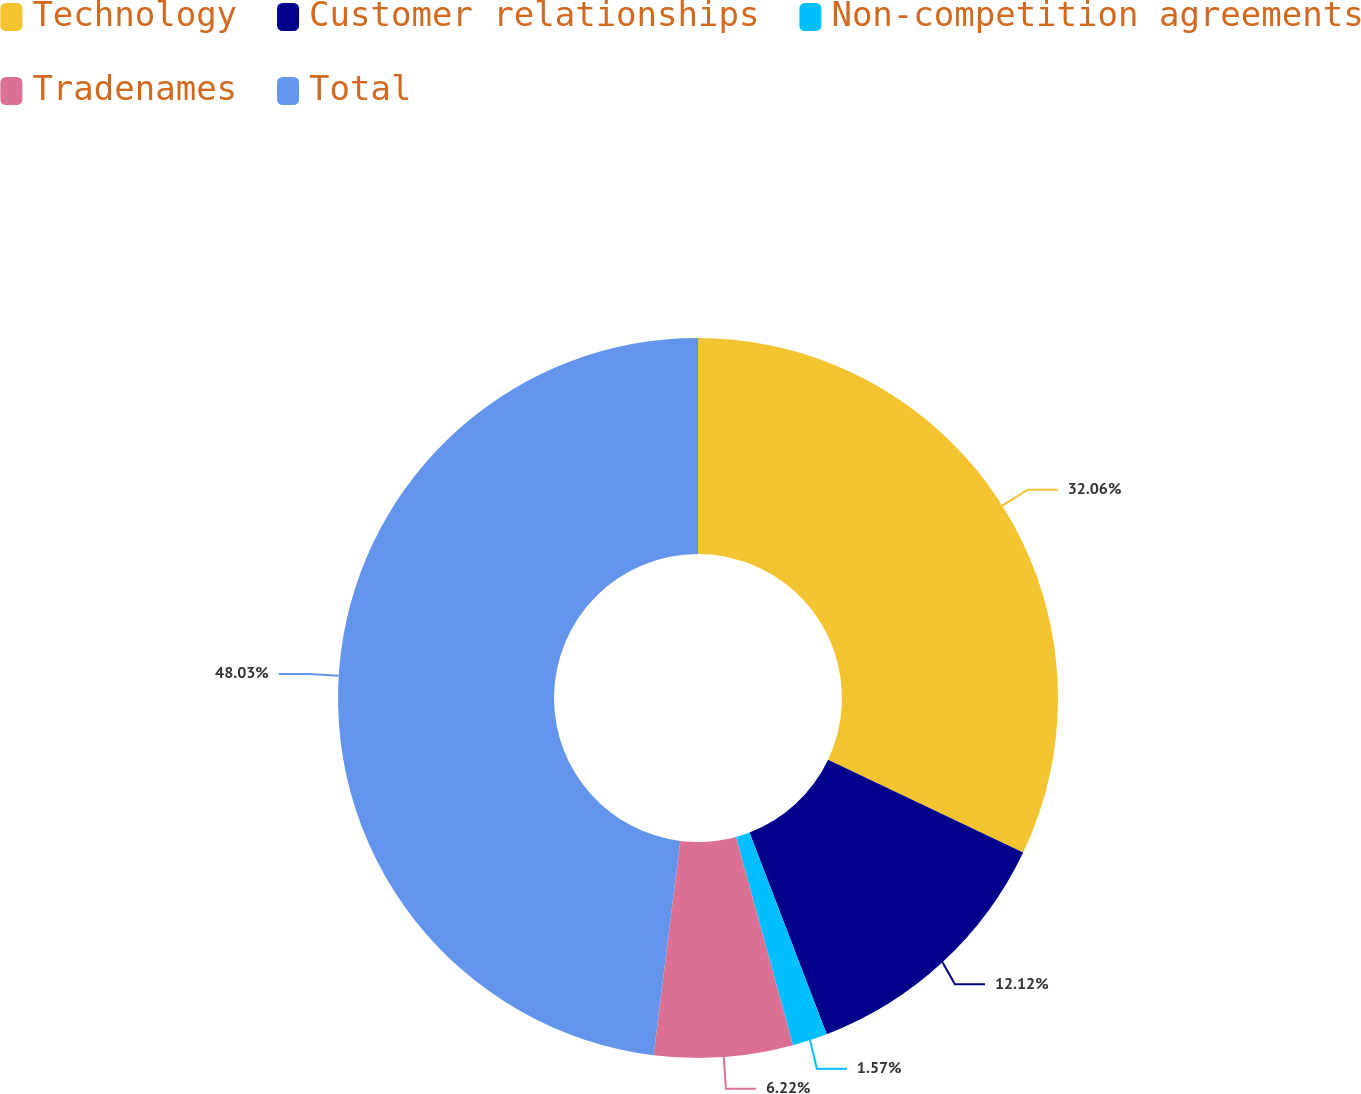Convert chart. <chart><loc_0><loc_0><loc_500><loc_500><pie_chart><fcel>Technology<fcel>Customer relationships<fcel>Non-competition agreements<fcel>Tradenames<fcel>Total<nl><fcel>32.06%<fcel>12.12%<fcel>1.57%<fcel>6.22%<fcel>48.03%<nl></chart> 